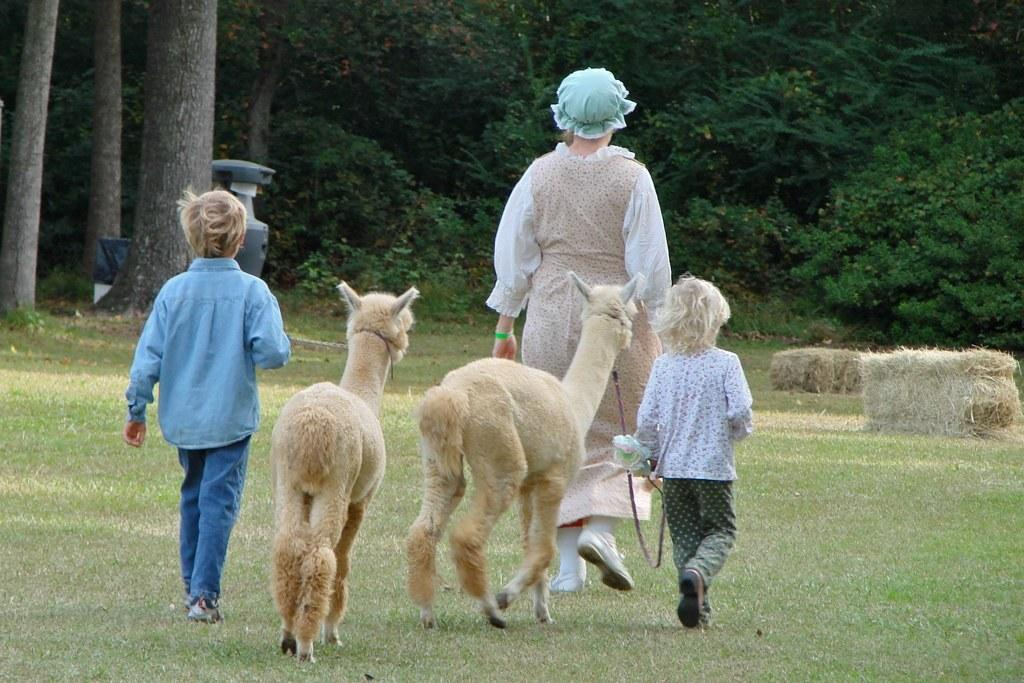Who or what can be seen in the image? There are people and animals in the image. What are the animals doing in the image? The animals are walking on the grass in the image. What can be seen in the background of the image? Trees, plants, tree trunks, and an unspecified object are visible in the background of the image. What type of vegetation is present in the background of the image? Dry grass is present in the background of the image. How many clocks are hanging from the trees in the image? There are no clocks hanging from the trees in the image. What type of garden can be seen in the image? There is no garden present in the image; it features people, animals, and vegetation in an outdoor setting. 